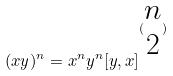<formula> <loc_0><loc_0><loc_500><loc_500>( x y ) ^ { n } = x ^ { n } y ^ { n } [ y , x ] ^ { ( \begin{matrix} n \\ 2 \end{matrix} ) }</formula> 